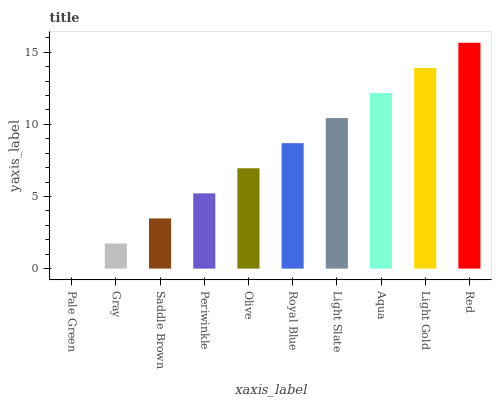Is Pale Green the minimum?
Answer yes or no. Yes. Is Red the maximum?
Answer yes or no. Yes. Is Gray the minimum?
Answer yes or no. No. Is Gray the maximum?
Answer yes or no. No. Is Gray greater than Pale Green?
Answer yes or no. Yes. Is Pale Green less than Gray?
Answer yes or no. Yes. Is Pale Green greater than Gray?
Answer yes or no. No. Is Gray less than Pale Green?
Answer yes or no. No. Is Royal Blue the high median?
Answer yes or no. Yes. Is Olive the low median?
Answer yes or no. Yes. Is Saddle Brown the high median?
Answer yes or no. No. Is Red the low median?
Answer yes or no. No. 